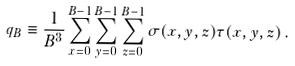Convert formula to latex. <formula><loc_0><loc_0><loc_500><loc_500>q _ { B } \equiv \frac { 1 } { B ^ { 3 } } \sum _ { x = 0 } ^ { B - 1 } \sum _ { y = 0 } ^ { B - 1 } \sum _ { z = 0 } ^ { B - 1 } \sigma ( x , y , z ) \tau ( x , y , z ) \, .</formula> 